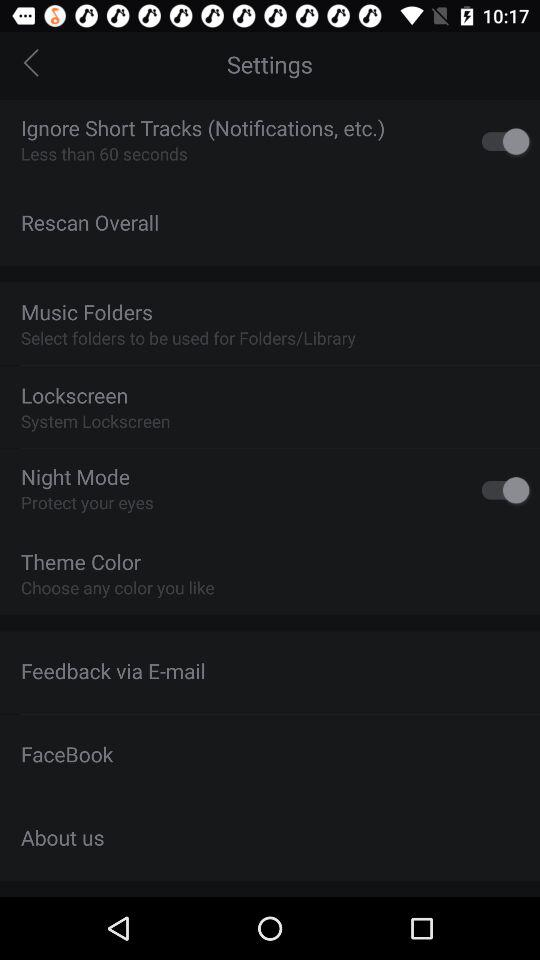What is the status of "Night Mode"? The status is off. 